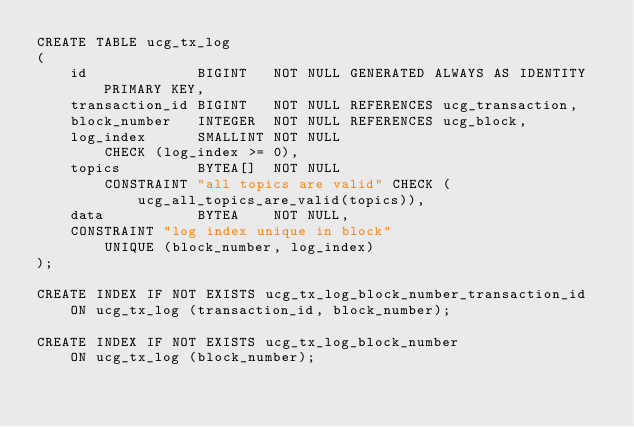<code> <loc_0><loc_0><loc_500><loc_500><_SQL_>CREATE TABLE ucg_tx_log
(
    id             BIGINT   NOT NULL GENERATED ALWAYS AS IDENTITY PRIMARY KEY,
    transaction_id BIGINT   NOT NULL REFERENCES ucg_transaction,
    block_number   INTEGER  NOT NULL REFERENCES ucg_block,
    log_index      SMALLINT NOT NULL
        CHECK (log_index >= 0),
    topics         BYTEA[]  NOT NULL
        CONSTRAINT "all topics are valid" CHECK (ucg_all_topics_are_valid(topics)),
    data           BYTEA    NOT NULL,
    CONSTRAINT "log index unique in block"
        UNIQUE (block_number, log_index)
);

CREATE INDEX IF NOT EXISTS ucg_tx_log_block_number_transaction_id
    ON ucg_tx_log (transaction_id, block_number);

CREATE INDEX IF NOT EXISTS ucg_tx_log_block_number
    ON ucg_tx_log (block_number);
</code> 